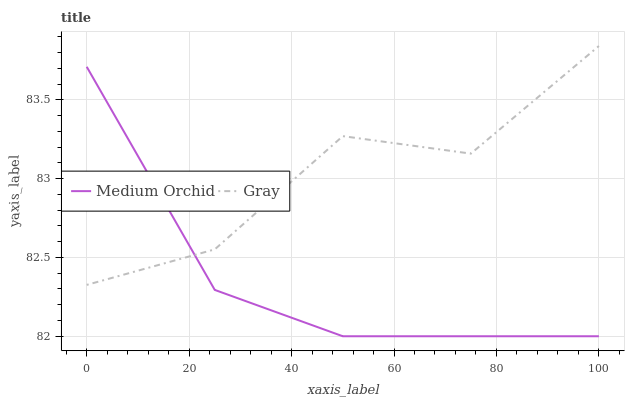Does Medium Orchid have the minimum area under the curve?
Answer yes or no. Yes. Does Gray have the maximum area under the curve?
Answer yes or no. Yes. Does Medium Orchid have the maximum area under the curve?
Answer yes or no. No. Is Medium Orchid the smoothest?
Answer yes or no. Yes. Is Gray the roughest?
Answer yes or no. Yes. Is Medium Orchid the roughest?
Answer yes or no. No. Does Medium Orchid have the lowest value?
Answer yes or no. Yes. Does Gray have the highest value?
Answer yes or no. Yes. Does Medium Orchid have the highest value?
Answer yes or no. No. Does Medium Orchid intersect Gray?
Answer yes or no. Yes. Is Medium Orchid less than Gray?
Answer yes or no. No. Is Medium Orchid greater than Gray?
Answer yes or no. No. 